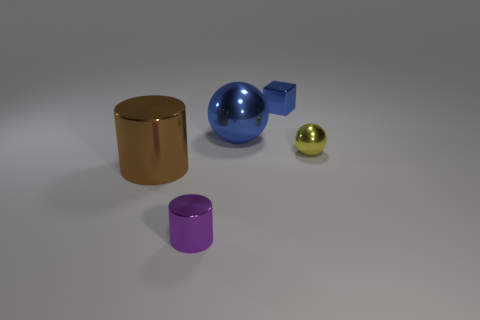Add 3 big blue things. How many objects exist? 8 Subtract all cylinders. How many objects are left? 3 Subtract all small purple things. Subtract all large yellow matte objects. How many objects are left? 4 Add 2 tiny blocks. How many tiny blocks are left? 3 Add 4 large blue rubber balls. How many large blue rubber balls exist? 4 Subtract 0 brown balls. How many objects are left? 5 